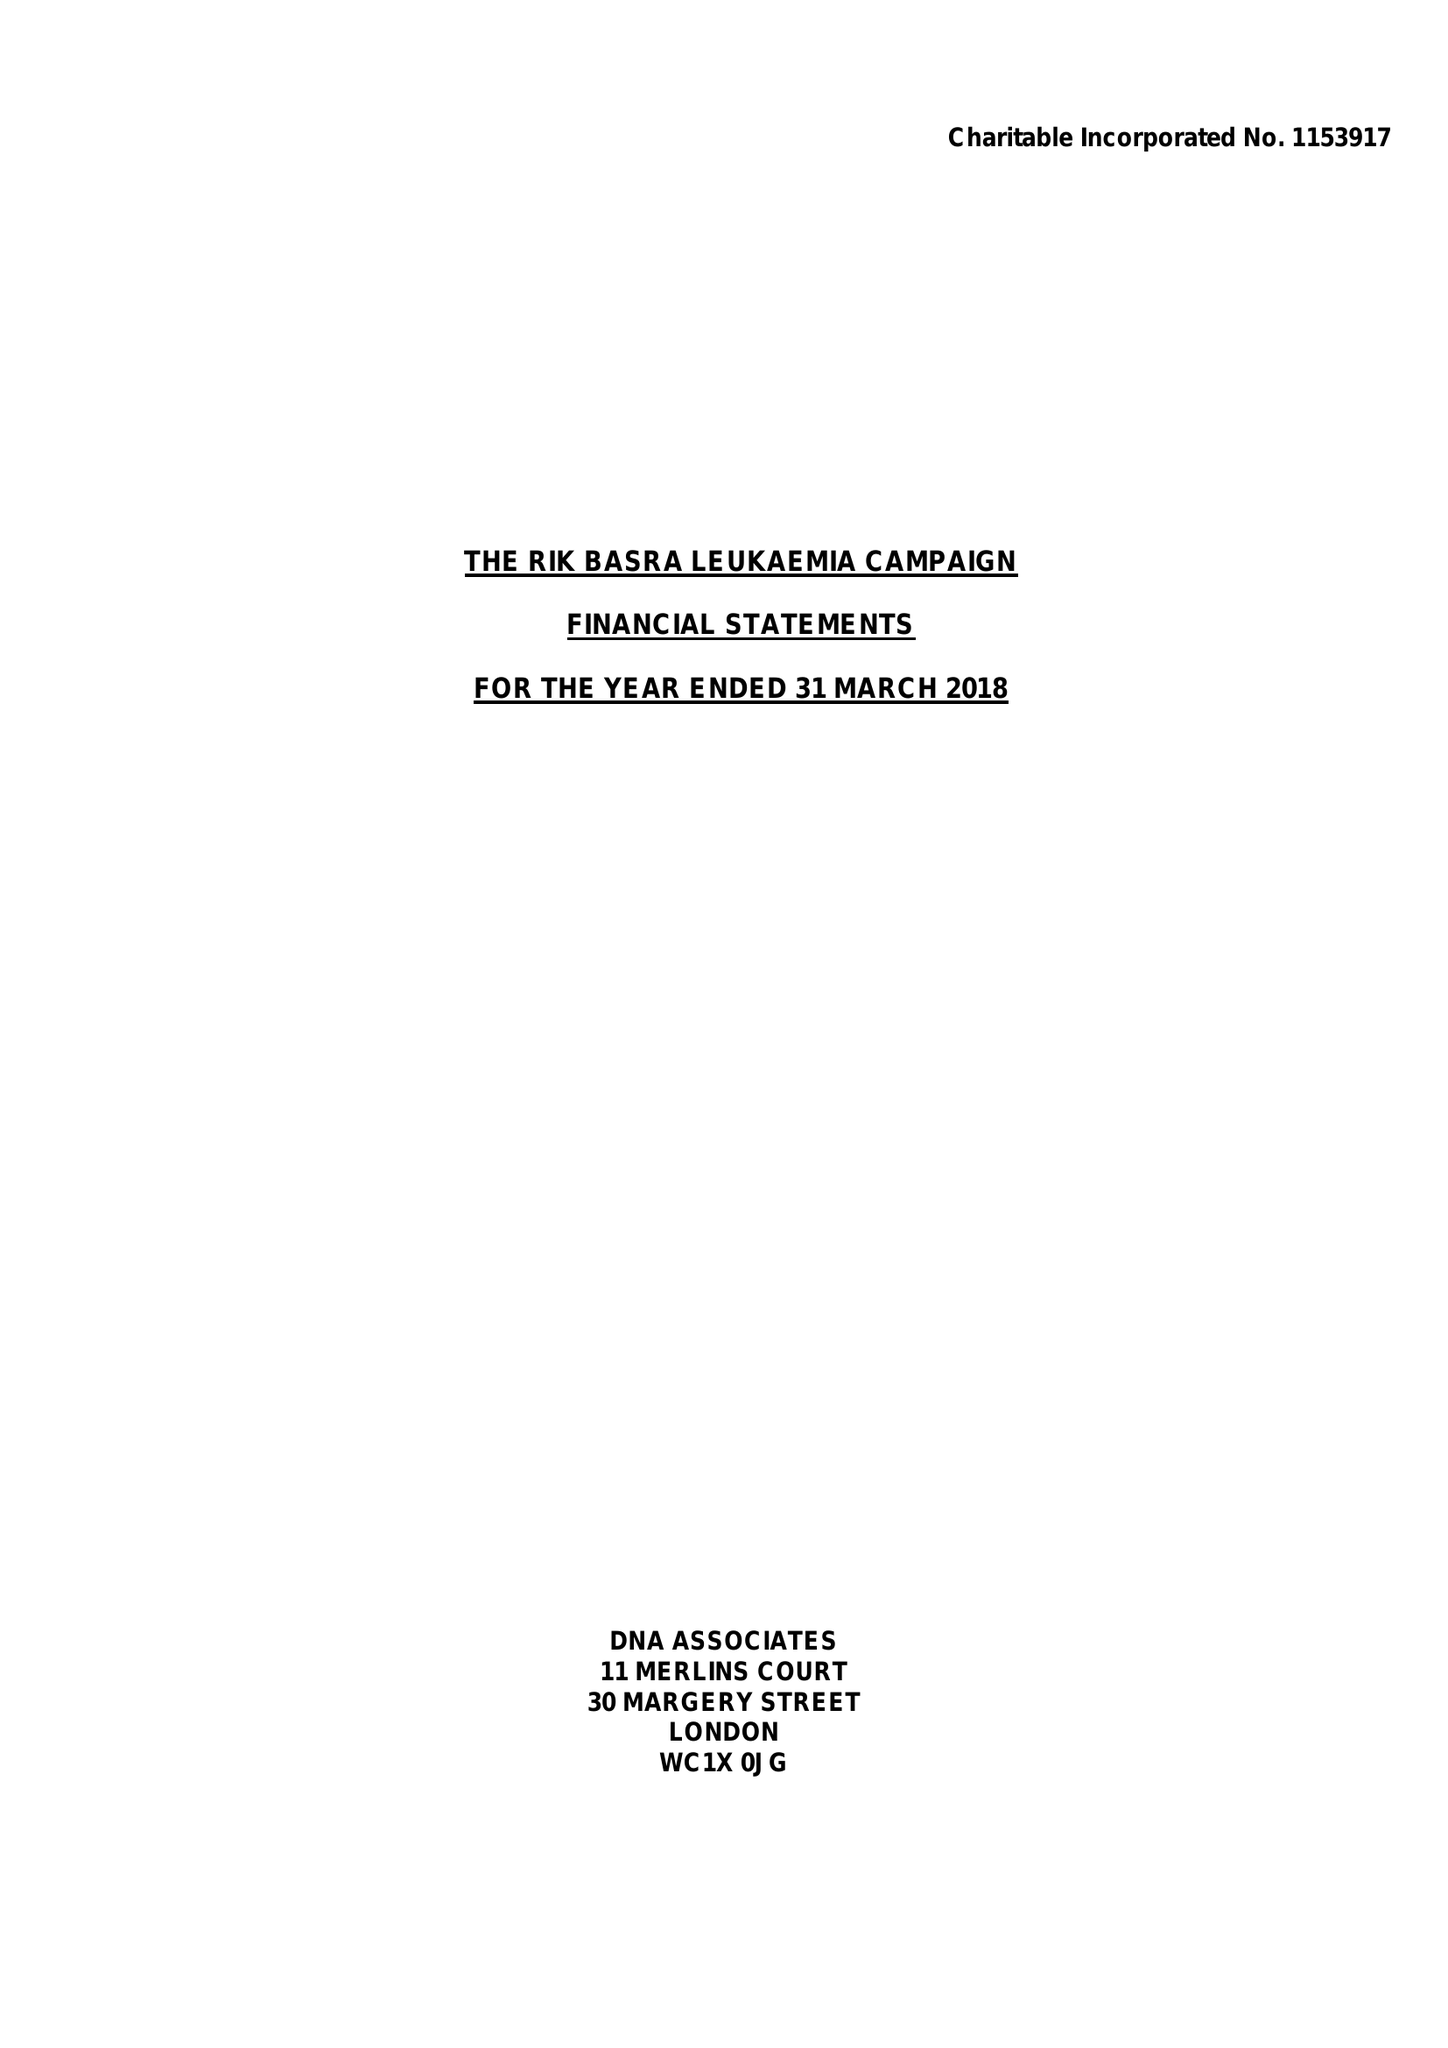What is the value for the charity_number?
Answer the question using a single word or phrase. 1153917 